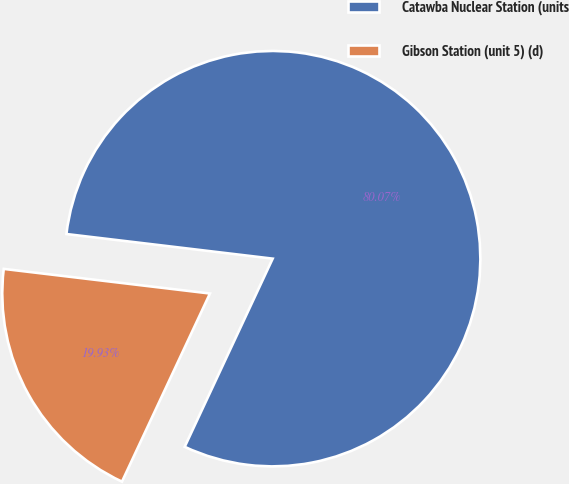<chart> <loc_0><loc_0><loc_500><loc_500><pie_chart><fcel>Catawba Nuclear Station (units<fcel>Gibson Station (unit 5) (d)<nl><fcel>80.07%<fcel>19.93%<nl></chart> 